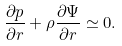<formula> <loc_0><loc_0><loc_500><loc_500>\frac { \partial p } { \partial r } + \rho \frac { \partial \Psi } { \partial r } \simeq 0 .</formula> 